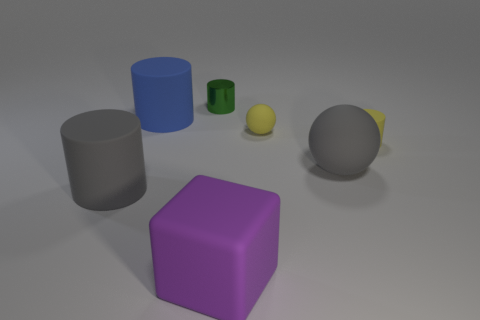Do the tiny metal cylinder and the rubber block have the same color?
Your answer should be compact. No. Are there any other things that have the same shape as the big purple matte object?
Give a very brief answer. No. Is the number of yellow cylinders less than the number of tiny gray rubber balls?
Provide a succinct answer. No. There is a cylinder that is right of the big gray matte thing to the right of the yellow rubber ball; what color is it?
Ensure brevity in your answer.  Yellow. There is a ball that is behind the rubber thing to the right of the ball that is in front of the yellow matte ball; what is it made of?
Provide a short and direct response. Rubber. Does the object that is to the right of the gray sphere have the same size as the purple block?
Provide a succinct answer. No. What is the gray object right of the large purple matte block made of?
Your answer should be very brief. Rubber. Is the number of large matte cylinders greater than the number of tiny green cylinders?
Provide a succinct answer. Yes. How many things are rubber cylinders on the left side of the purple thing or matte blocks?
Provide a succinct answer. 3. There is a gray matte thing that is to the left of the large blue rubber thing; what number of yellow things are on the right side of it?
Offer a terse response. 2. 